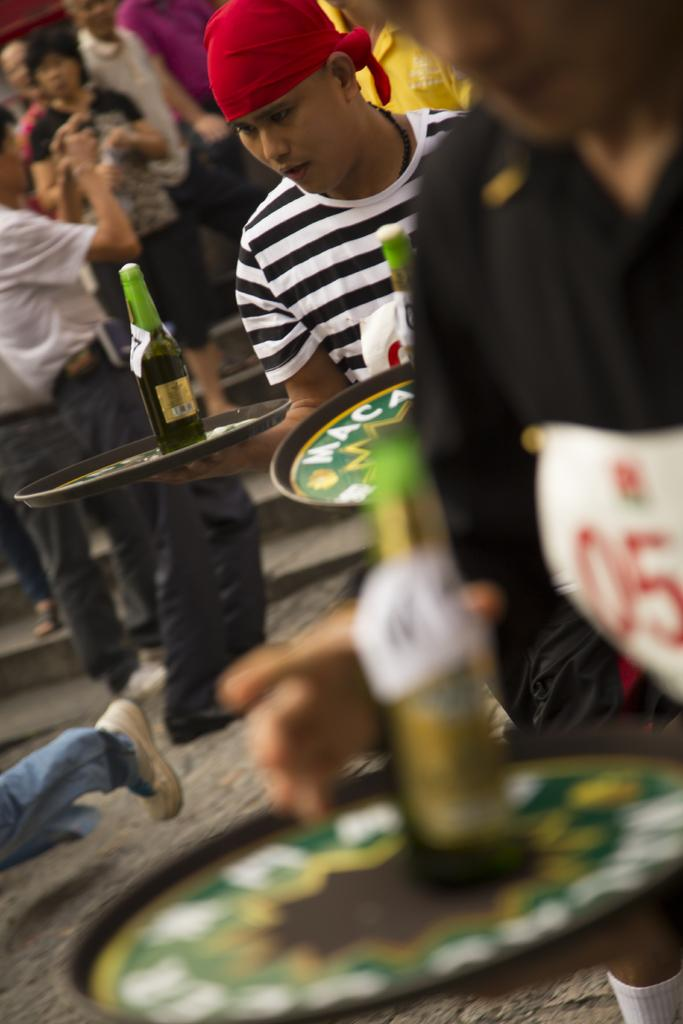What are the persons in the image doing? The persons in the image are standing on the ground. Can you describe what some of the persons are holding? Some of the persons are carrying beverage bottles in trays on their hands. What decision does the queen make in the image? There is no queen present in the image, so no decision can be made by a queen. 